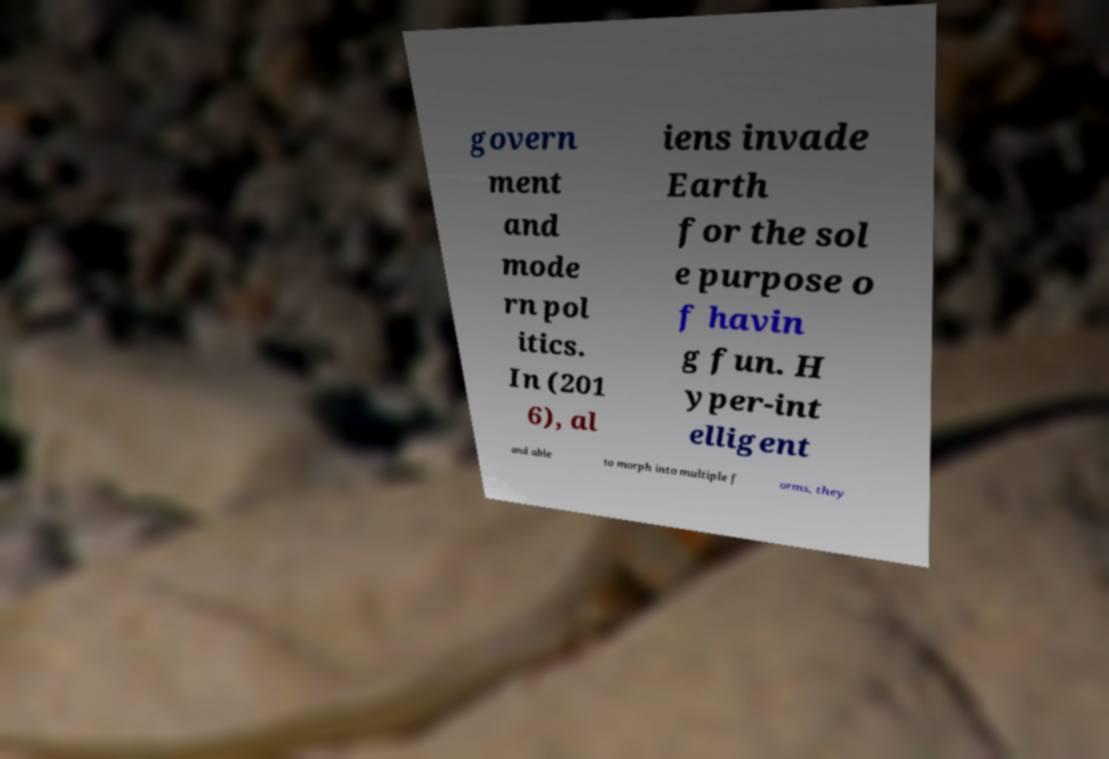There's text embedded in this image that I need extracted. Can you transcribe it verbatim? govern ment and mode rn pol itics. In (201 6), al iens invade Earth for the sol e purpose o f havin g fun. H yper-int elligent and able to morph into multiple f orms, they 